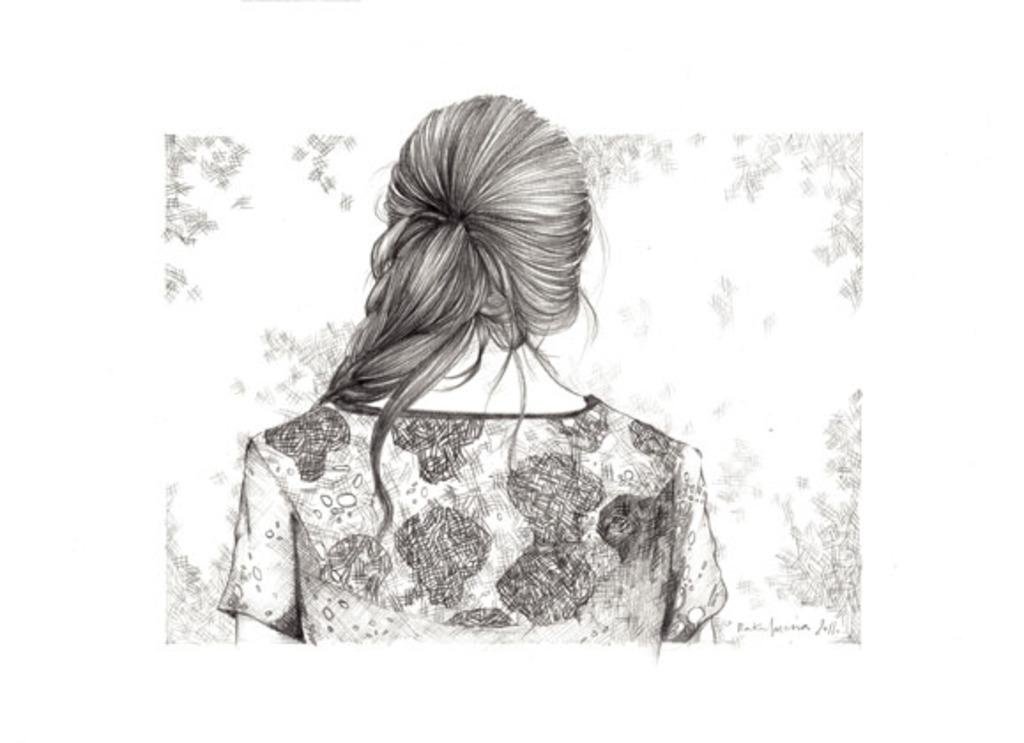What is the main subject of the image? There is a sketch in the image. What is depicted in the sketch? The sketch contains a depiction of a person. How many boots are being distributed by the person in the sketch? There are no boots mentioned or depicted in the image, as it only contains a sketch of a person. 